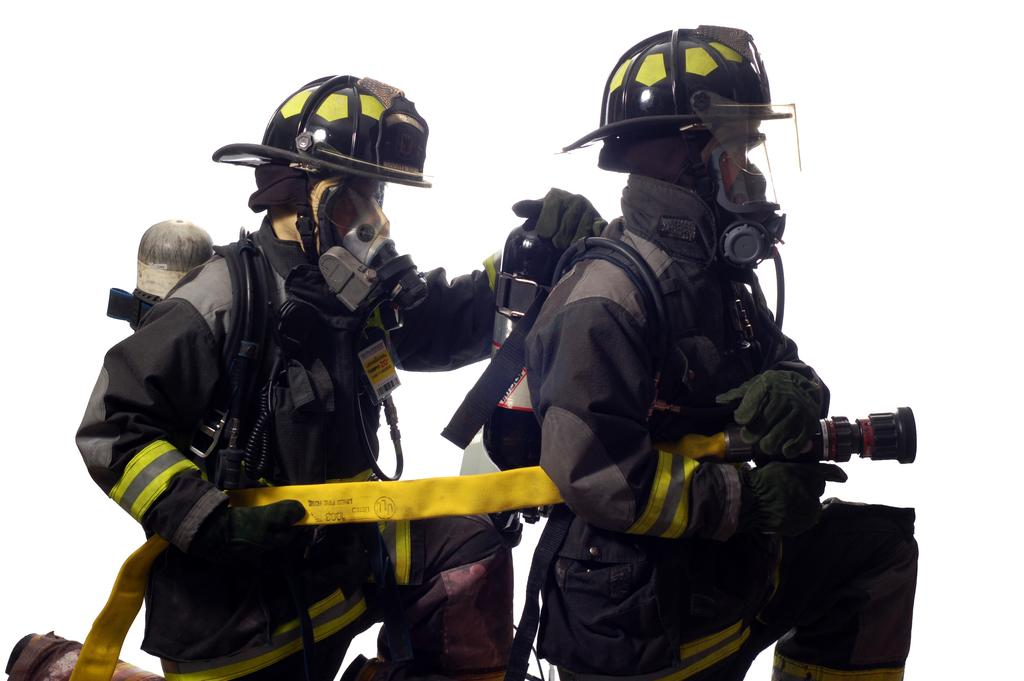How many people are in the image? There are two persons in the image. What are the persons wearing on their heads? The persons are wearing helmets. What type of clothing are the persons wearing on their upper bodies? The persons are wearing jackets. What is the color of the background in the image? The background of the image is white. What type of door can be seen in the image? There is no door present in the image. What kind of yarn is being used by the persons in the image? There is no yarn visible in the image. 